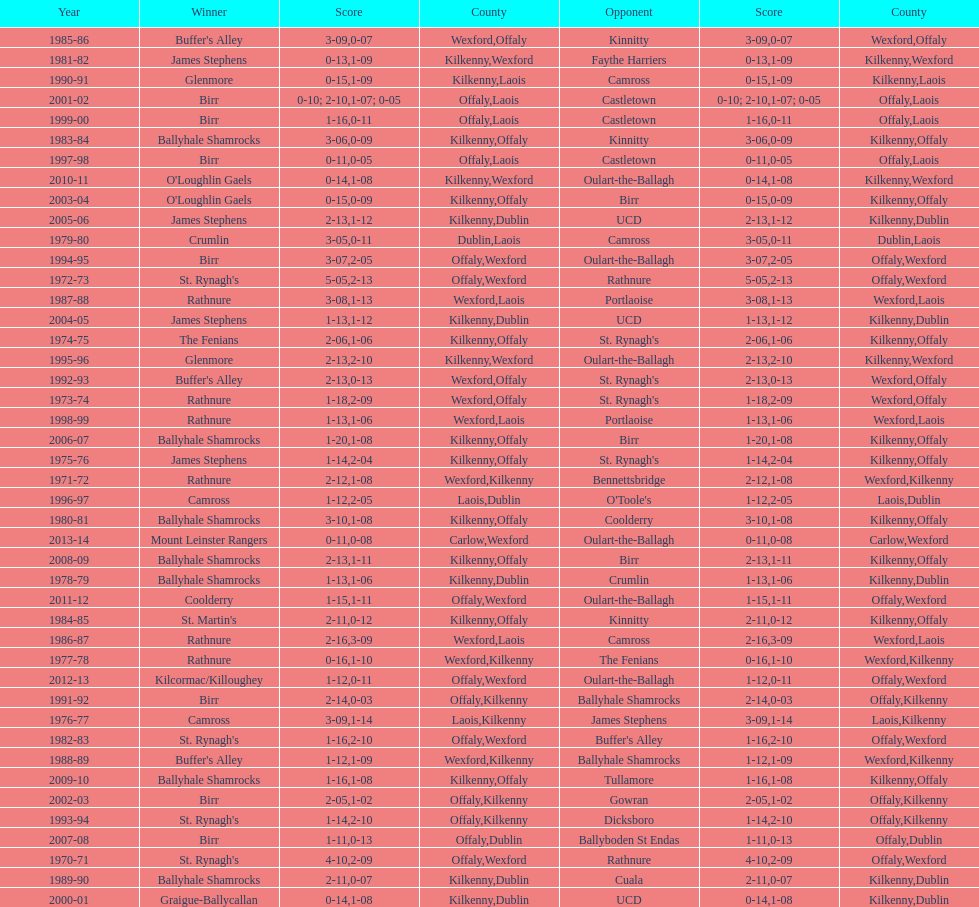Which winner is next to mount leinster rangers? Kilcormac/Killoughey. 